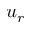Convert formula to latex. <formula><loc_0><loc_0><loc_500><loc_500>u _ { r }</formula> 